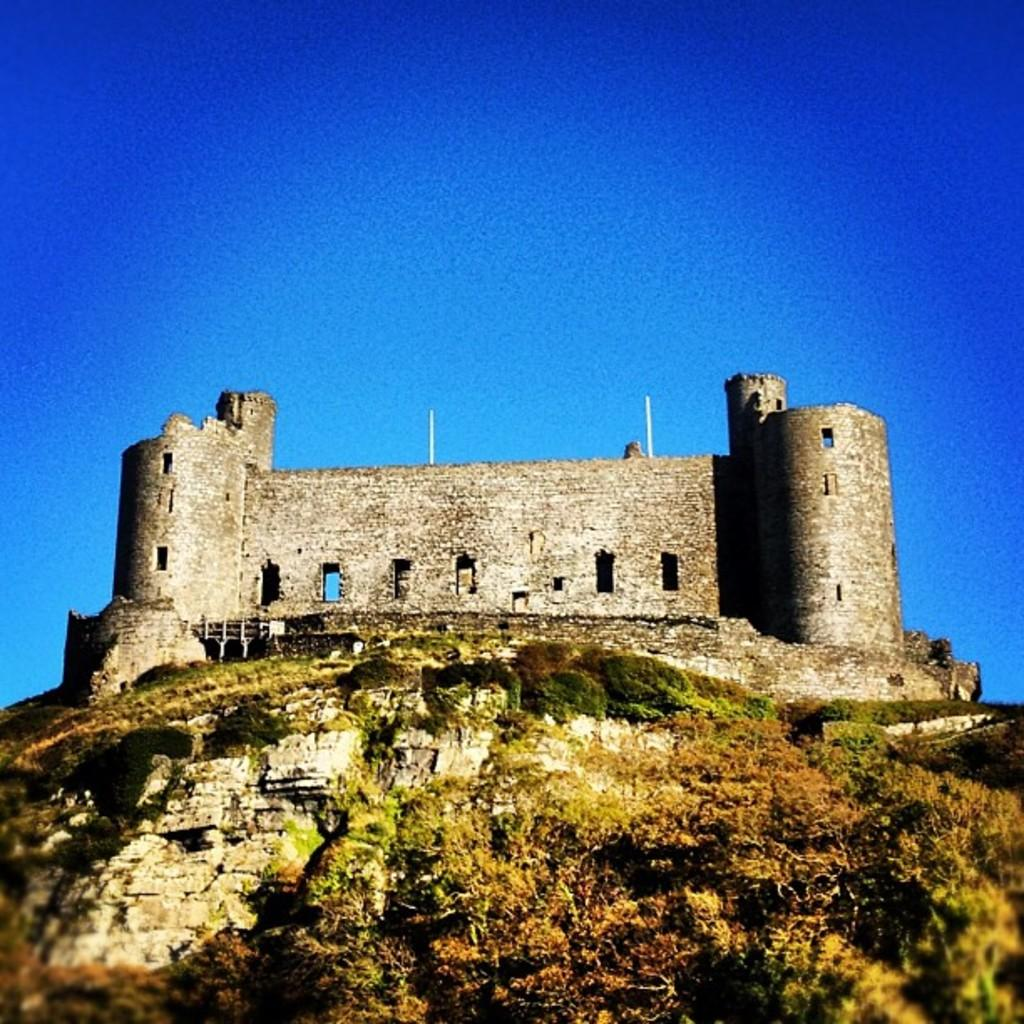What is the main subject of the picture? There is a monument in the picture. What can be seen in the background of the picture? There are trees visible in the picture. What is the color of the sky in the picture? The sky is blue in the picture. How much debt is the monument in the picture responsible for? There is no information about the monument's debt in the image, as it is not relevant to the visual content. 